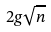<formula> <loc_0><loc_0><loc_500><loc_500>2 g \sqrt { n }</formula> 